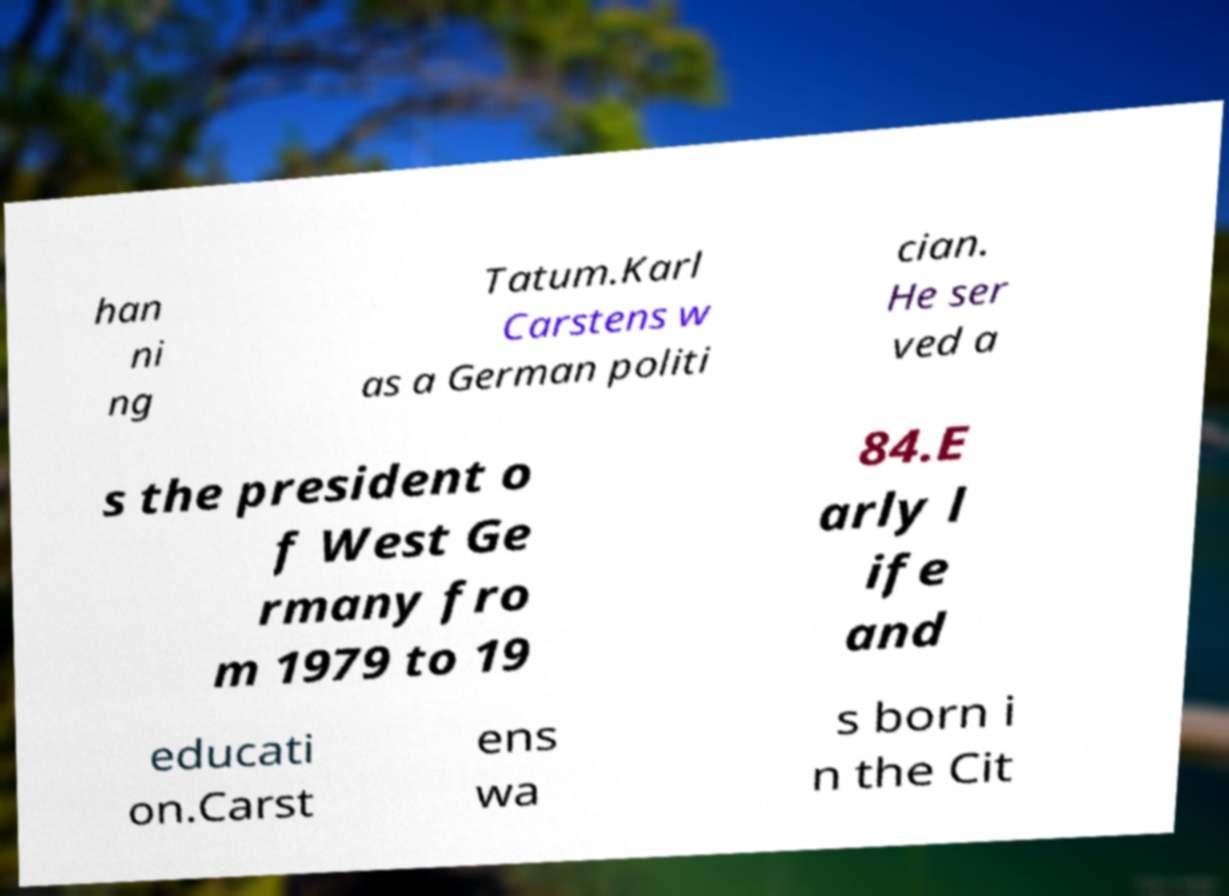For documentation purposes, I need the text within this image transcribed. Could you provide that? han ni ng Tatum.Karl Carstens w as a German politi cian. He ser ved a s the president o f West Ge rmany fro m 1979 to 19 84.E arly l ife and educati on.Carst ens wa s born i n the Cit 